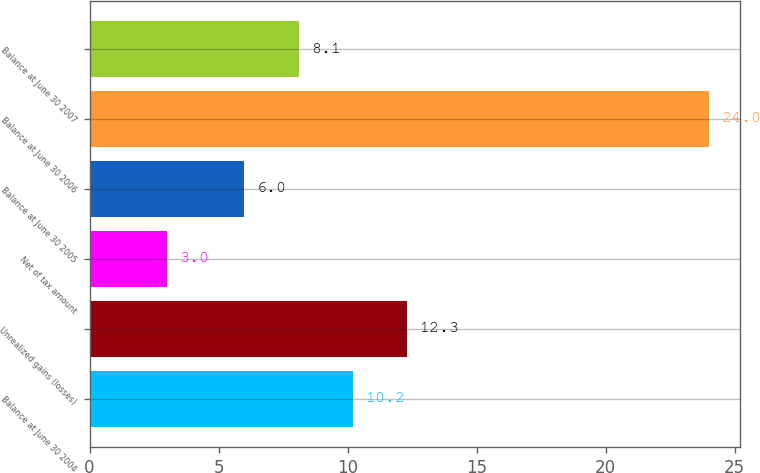Convert chart. <chart><loc_0><loc_0><loc_500><loc_500><bar_chart><fcel>Balance at June 30 2004<fcel>Unrealized gains (losses)<fcel>Net of tax amount<fcel>Balance at June 30 2005<fcel>Balance at June 30 2006<fcel>Balance at June 30 2007<nl><fcel>10.2<fcel>12.3<fcel>3<fcel>6<fcel>24<fcel>8.1<nl></chart> 